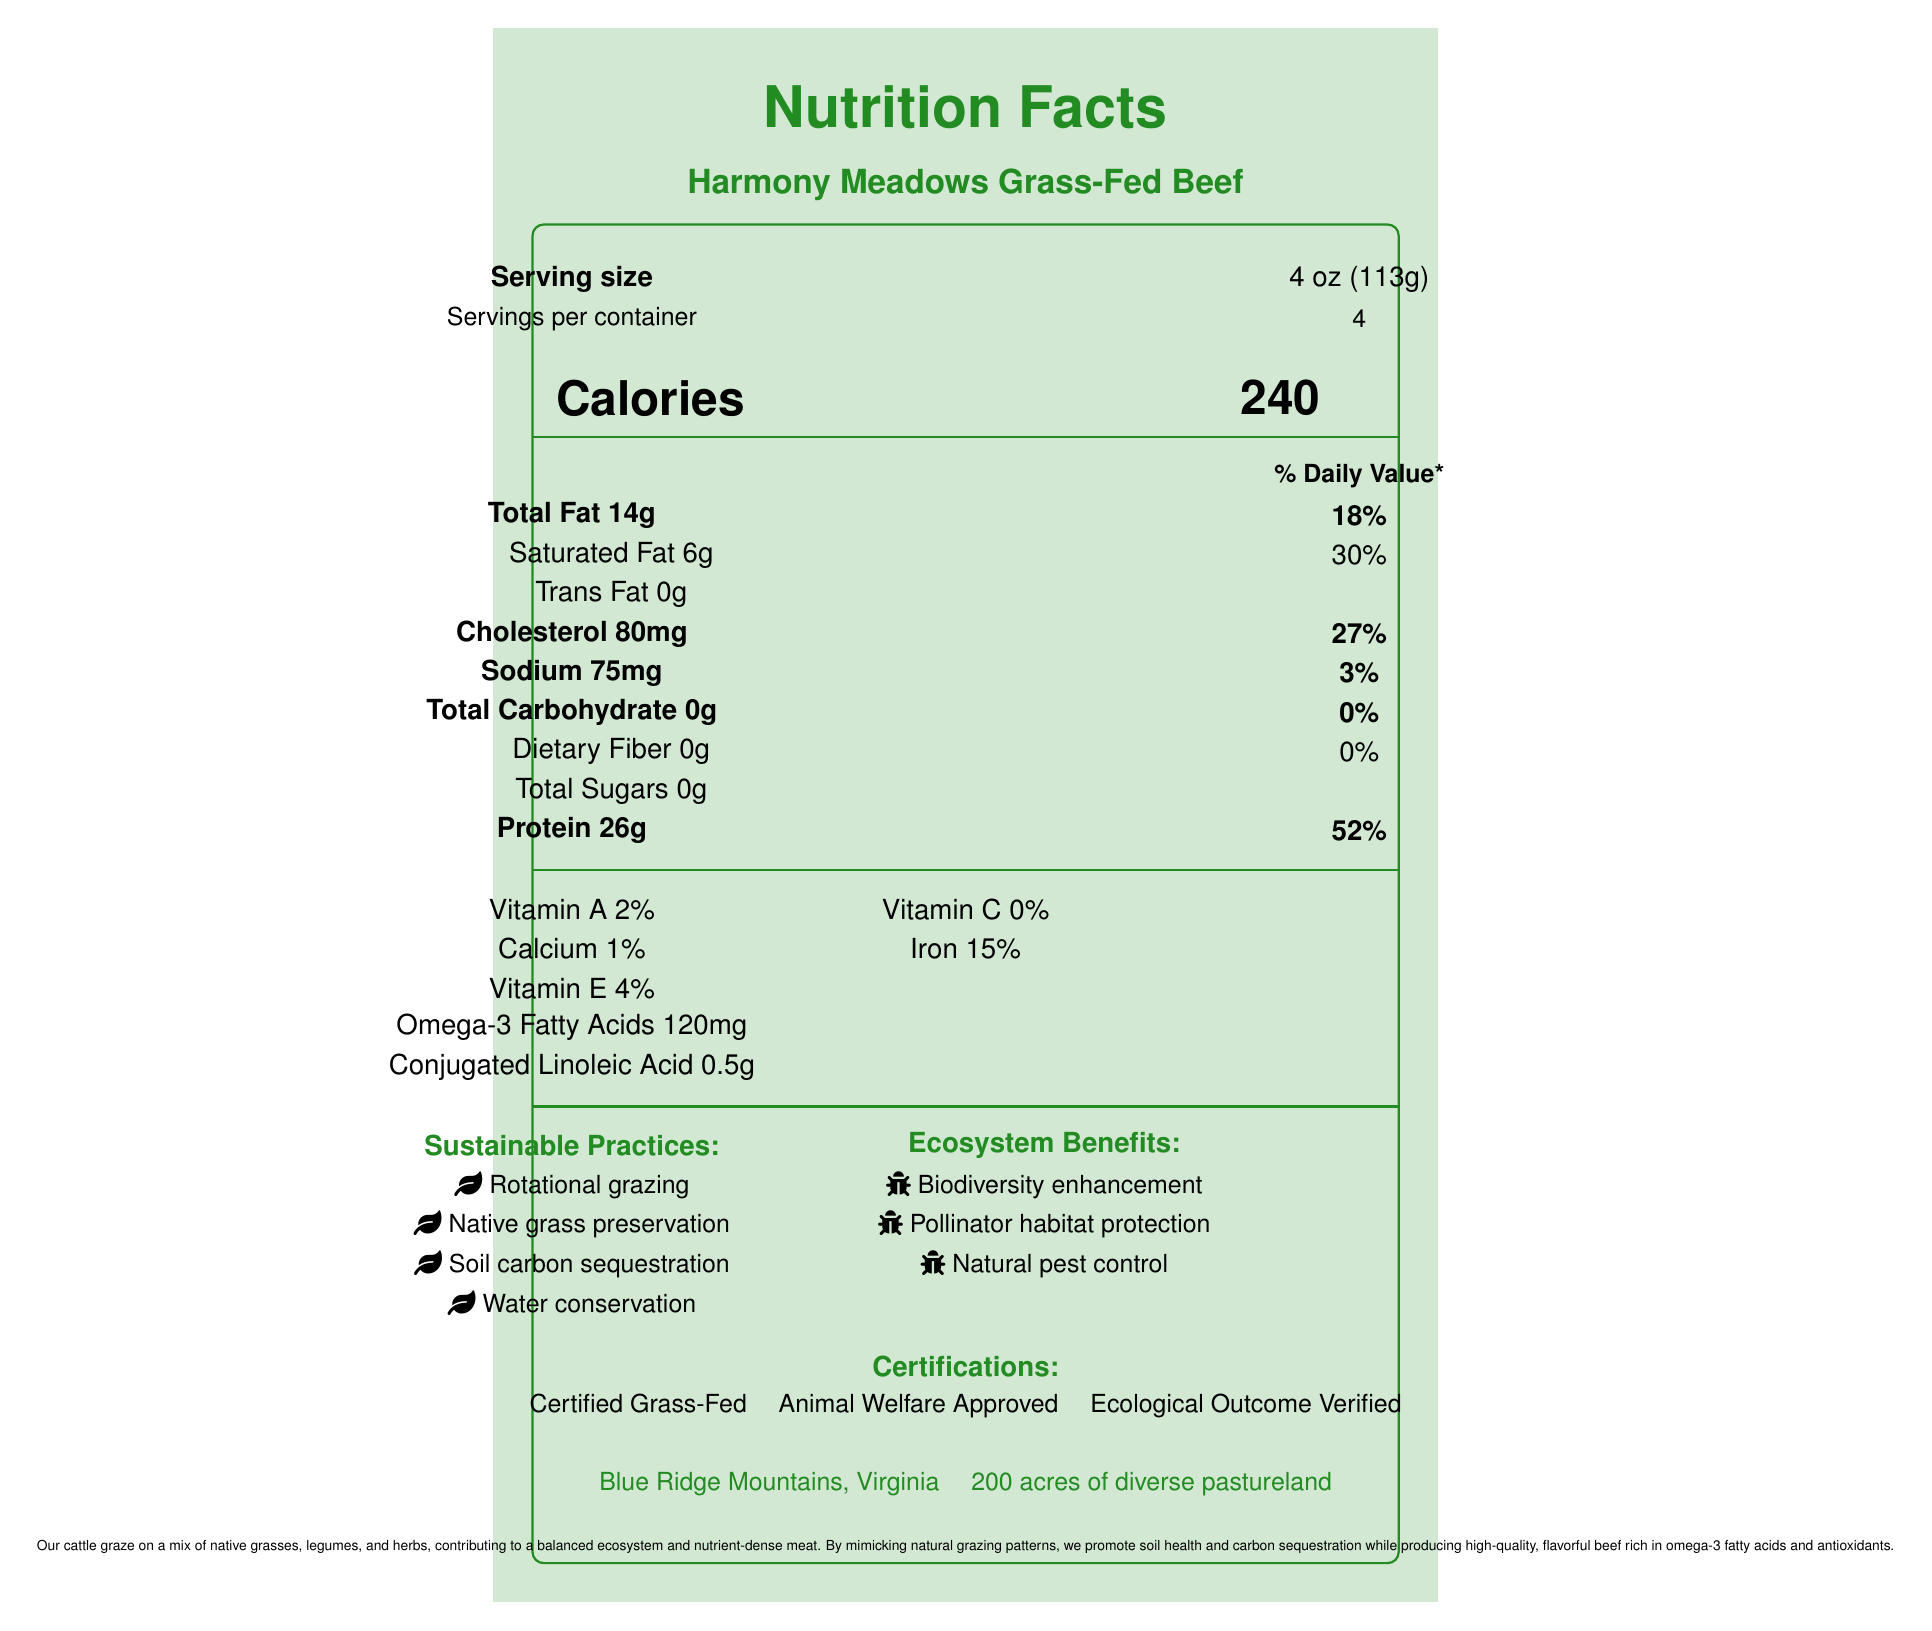what is the serving size for Harmony Meadows Grass-Fed Beef? The document specifies "Serving size" as 4 oz (113g).
Answer: 4 oz (113g) how many calories are in one serving? The document lists "Calories" as 240.
Answer: 240 how much protein does one serving of Harmony Meadows Grass-Fed Beef contain? Under the nutrient information, it states "Protein 26g".
Answer: 26g what are the sustainable practices mentioned in the document? The document lists these practices under the "Sustainable Practices" section.
Answer: Rotational grazing, Native grass preservation, Soil carbon sequestration, Water conservation where is Harmony Meadows located? The document specifies "Blue Ridge Mountains, Virginia" under the farm information.
Answer: Blue Ridge Mountains, Virginia how many servings are there in one container? The document mentions "Servings per container: 4".
Answer: 4 which certification is not listed for Harmony Meadows Grass-Fed Beef? A. Certified Organic B. Certified Grass-Fed C. Animal Welfare Approved D. Ecological Outcome Verified The document lists "Certified Grass-Fed", "Animal Welfare Approved", and "Ecological Outcome Verified", but not "Certified Organic".
Answer: A. Certified Organic what is the percentage of daily value for iron provided by one serving? A. 2% B. 15% C. 27% D. 52% The document lists "Iron 15%" under the vitamins and minerals section.
Answer: B. 15% does the product contain any trans fat? The document lists "Trans Fat 0g", indicating there is no trans fat.
Answer: No summarize the main idea of the document. The document emphasizes the nutritional content of the beef and the sustainable practices used to produce it, highlighting its environmental benefits and certifications.
Answer: The document provides the nutrition facts for Harmony Meadows Grass-Fed Beef, highlighting its sustainable grazing methods and ecosystem benefits. The beef is noted for being rich in omega-3 fatty acids and is certified grass-fed, animal welfare approved, and ecologically verified. what types of ecosystems benefits are mentioned? The document lists these benefits under the "Ecosystem Benefits" section.
Answer: Biodiversity enhancement, Pollinator habitat protection, Natural pest control how much cholesterol is in one serving? The document states "Cholesterol 80mg".
Answer: 80mg what are the percentages of vitamin A and vitamin E in one serving? The document lists "Vitamin A 2%" and "Vitamin E 4%" under the vitamin information.
Answer: Vitamin A: 2%, Vitamin E: 4% how many units of Omega-3 fatty acids are in one serving? The document specifies "Omega-3 Fatty Acids 120mg".
Answer: 120mg what is the farm size of Harmony Meadows? The document mentions "200 acres of diverse pastureland" under the farm information.
Answer: 200 acres of diverse pastureland why might someone choose Harmony Meadows Grass-Fed Beef based on the document? The document highlights its high nutritional value, sustainable grazing practices, and ecosystem benefits.
Answer: The beef is nutritious, sustainably produced, and environmentally friendly. how much fiber is in one serving? The document lists "Dietary Fiber 0g".
Answer: 0g what types of grasses and plants do the cattle graze on? The document mentions the cattle graze on a mix of native grasses, legumes, and herbs, but does not specify the types.
Answer: Cannot be determined 